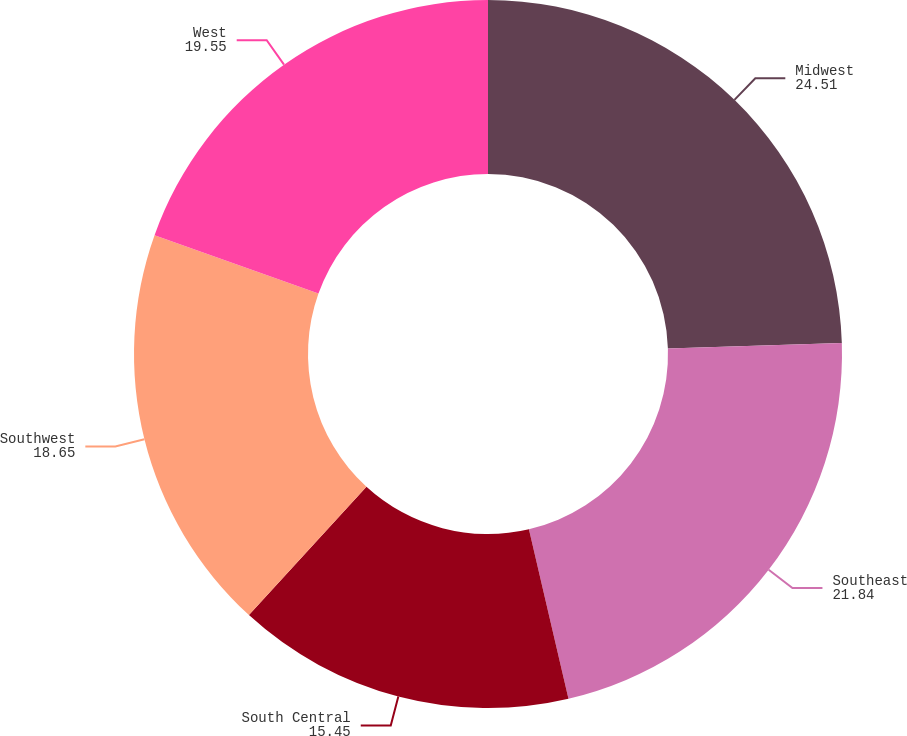<chart> <loc_0><loc_0><loc_500><loc_500><pie_chart><fcel>Midwest<fcel>Southeast<fcel>South Central<fcel>Southwest<fcel>West<nl><fcel>24.51%<fcel>21.84%<fcel>15.45%<fcel>18.65%<fcel>19.55%<nl></chart> 